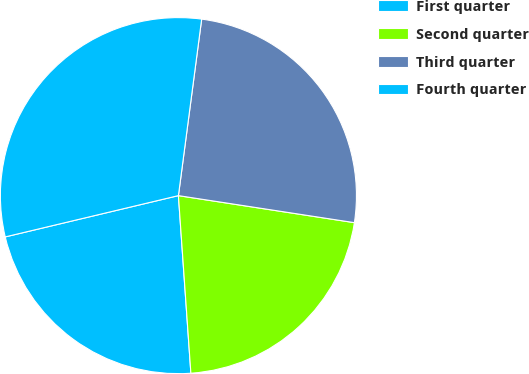<chart> <loc_0><loc_0><loc_500><loc_500><pie_chart><fcel>First quarter<fcel>Second quarter<fcel>Third quarter<fcel>Fourth quarter<nl><fcel>22.39%<fcel>21.46%<fcel>25.34%<fcel>30.81%<nl></chart> 